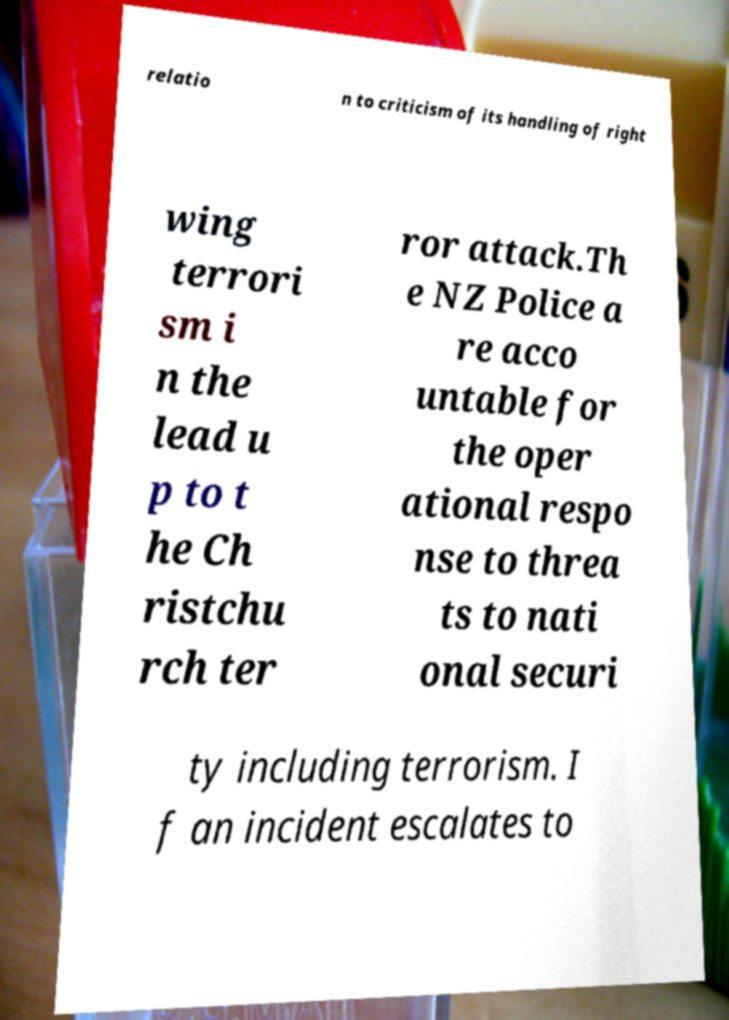Could you assist in decoding the text presented in this image and type it out clearly? relatio n to criticism of its handling of right wing terrori sm i n the lead u p to t he Ch ristchu rch ter ror attack.Th e NZ Police a re acco untable for the oper ational respo nse to threa ts to nati onal securi ty including terrorism. I f an incident escalates to 